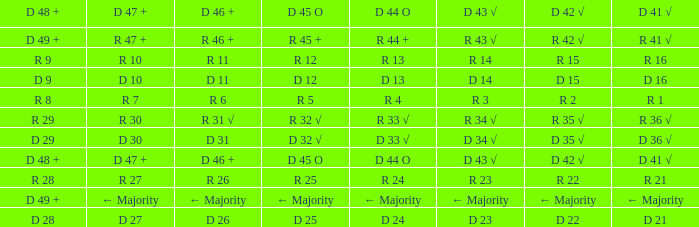What is the value of D 45 O when the value of D 44 O is ← majority? ← Majority. 